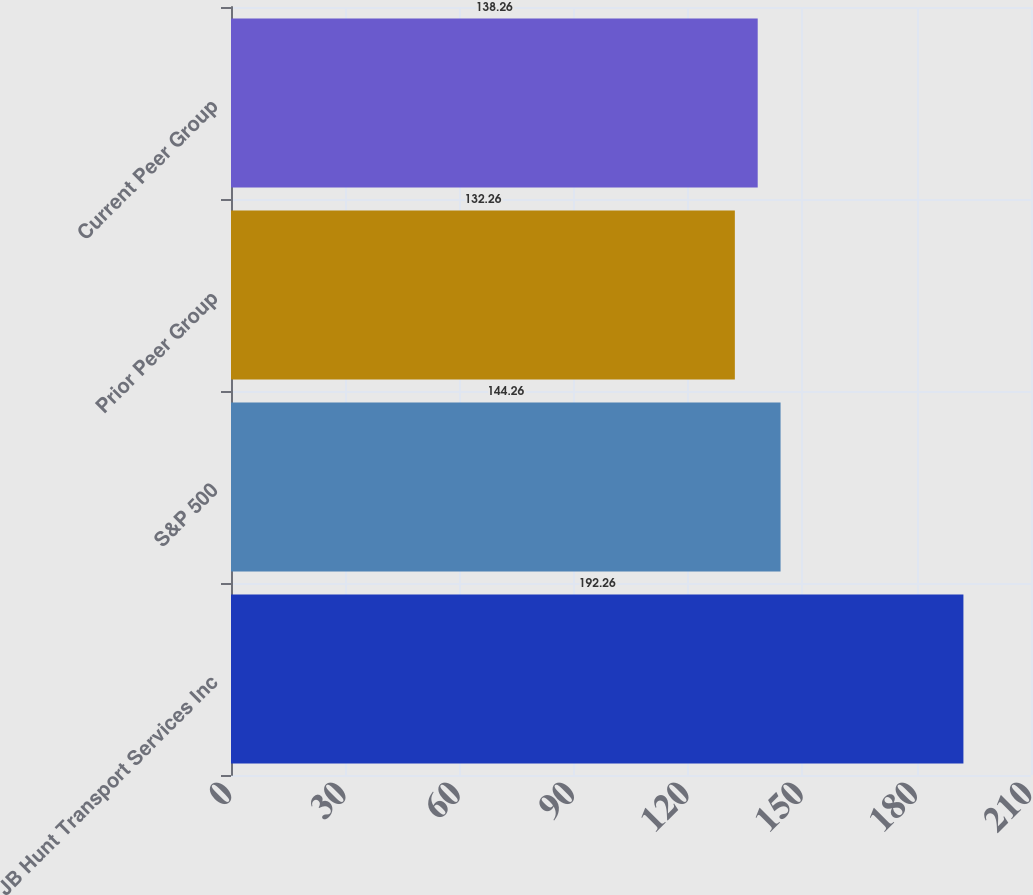<chart> <loc_0><loc_0><loc_500><loc_500><bar_chart><fcel>JB Hunt Transport Services Inc<fcel>S&P 500<fcel>Prior Peer Group<fcel>Current Peer Group<nl><fcel>192.26<fcel>144.26<fcel>132.26<fcel>138.26<nl></chart> 